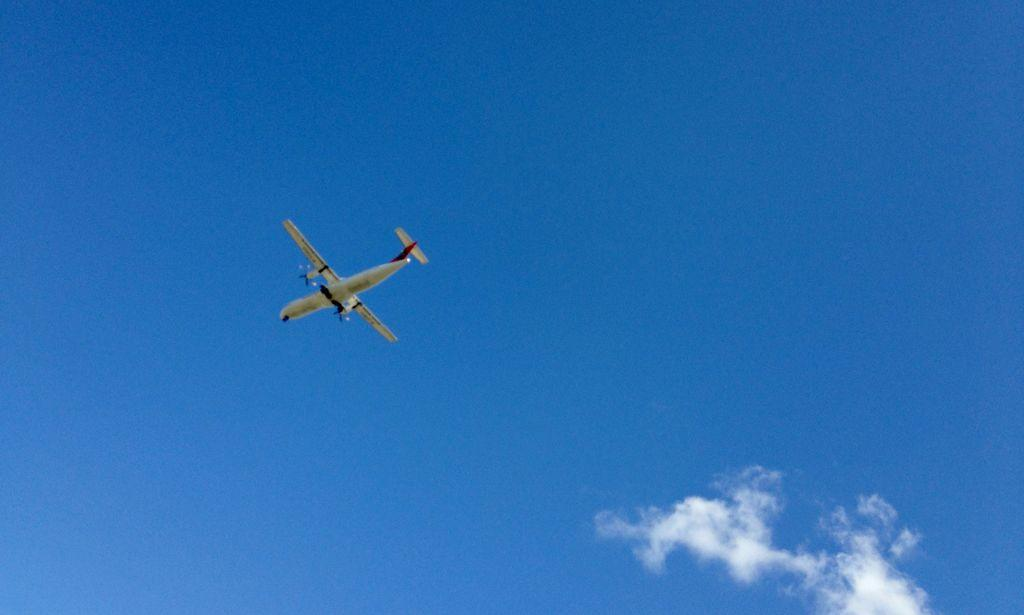What is the color of the sky in the image? The sky is blue in the image. Are there any clouds visible in the sky? Yes, the sky appears cloudy in the image. What is the main subject of the image? There is an airplane in the image. What feature of the airplane is mentioned in the facts? The airplane has wings. What is the airplane doing in the image? The airplane is flying in the air. What type of toys can be seen in the mouth of the airplane in the image? There are no toys or mouths present in the image; it features an airplane flying in the sky. 